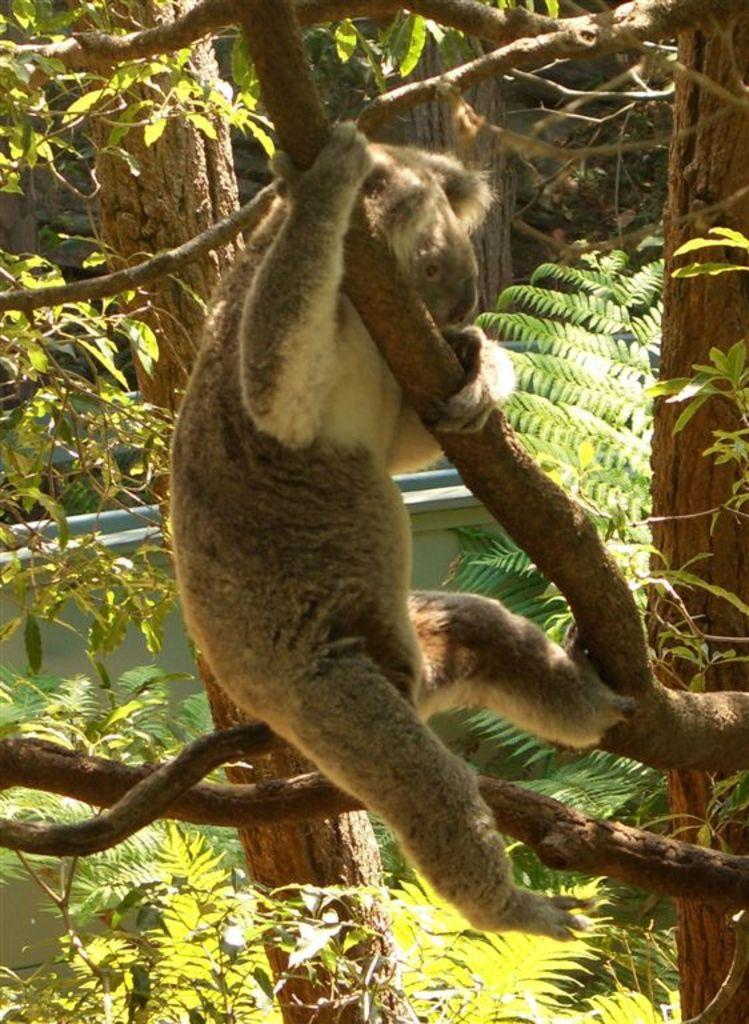What type of animal is in the image? There is an animal in the image, but its specific type cannot be determined from the provided facts. What color is the animal in the image? The animal is brown in color. Where is the animal located in the image? The animal is on a tree. What can be seen in the background of the image? There is water and trees with green leaves visible in the background of the image. What type of pin is the animal using to hold its argument in the image? There is no pin or argument present in the image; it features an animal on a tree with water and trees with green leaves in the background. 